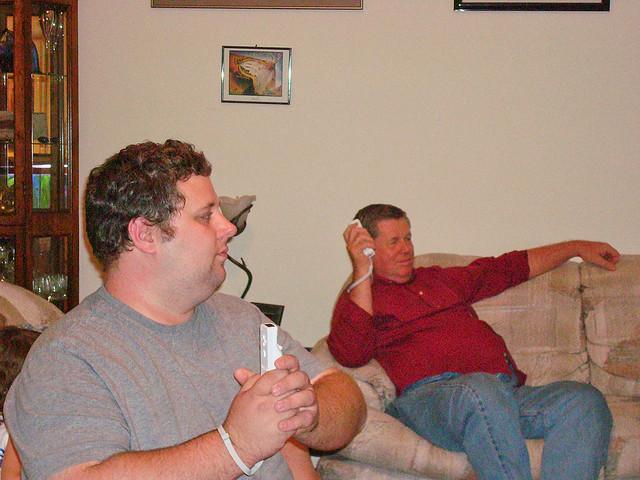What color is the shirt of the man on the sofa?
Quick response, please. Red. Is this porn?
Concise answer only. No. Is the man in the picture wearing glasses?
Write a very short answer. No. What is the man in the background holding?
Short answer required. Wii remote. What are they playing?
Answer briefly. Wii. How many remotes?
Be succinct. 2. How many people in the picture are wearing glasses?
Write a very short answer. 0. What is the person doing?
Quick response, please. Playing wii. What are these men doing?
Be succinct. Playing wii. Are they likely to be a couple?
Concise answer only. No. Is there a string of lights on the wall?
Answer briefly. No. Is the person on the left a man or a woman?
Give a very brief answer. Man. 